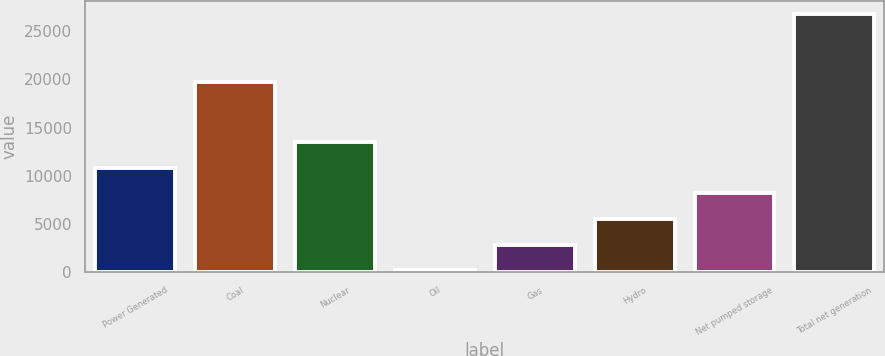<chart> <loc_0><loc_0><loc_500><loc_500><bar_chart><fcel>Power Generated<fcel>Coal<fcel>Nuclear<fcel>Oil<fcel>Gas<fcel>Hydro<fcel>Net pumped storage<fcel>Total net generation<nl><fcel>10854.6<fcel>19711<fcel>13512<fcel>225<fcel>2882.4<fcel>5539.8<fcel>8197.2<fcel>26799<nl></chart> 